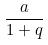Convert formula to latex. <formula><loc_0><loc_0><loc_500><loc_500>\frac { a } { 1 + q }</formula> 